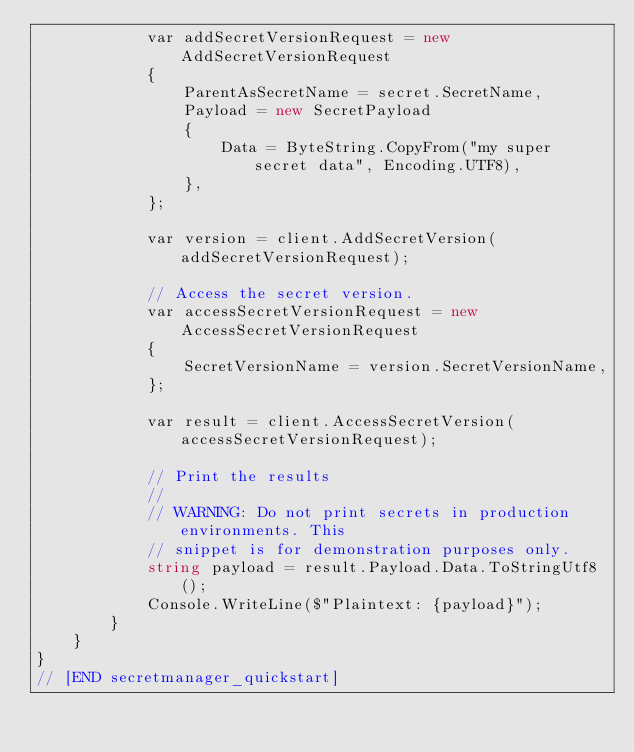Convert code to text. <code><loc_0><loc_0><loc_500><loc_500><_C#_>            var addSecretVersionRequest = new AddSecretVersionRequest
            {
                ParentAsSecretName = secret.SecretName,
                Payload = new SecretPayload
                {
                    Data = ByteString.CopyFrom("my super secret data", Encoding.UTF8),
                },
            };

            var version = client.AddSecretVersion(addSecretVersionRequest);

            // Access the secret version.
            var accessSecretVersionRequest = new AccessSecretVersionRequest
            {
                SecretVersionName = version.SecretVersionName,
            };

            var result = client.AccessSecretVersion(accessSecretVersionRequest);

            // Print the results
            //
            // WARNING: Do not print secrets in production environments. This
            // snippet is for demonstration purposes only.
            string payload = result.Payload.Data.ToStringUtf8();
            Console.WriteLine($"Plaintext: {payload}");
        }
    }
}
// [END secretmanager_quickstart]
</code> 